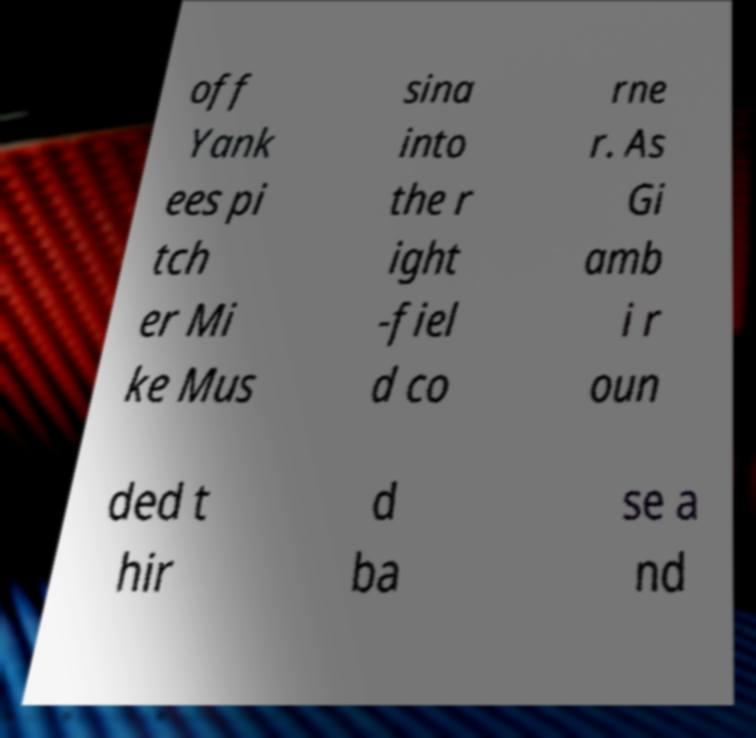Could you extract and type out the text from this image? off Yank ees pi tch er Mi ke Mus sina into the r ight -fiel d co rne r. As Gi amb i r oun ded t hir d ba se a nd 